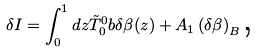Convert formula to latex. <formula><loc_0><loc_0><loc_500><loc_500>\delta I = \int _ { 0 } ^ { 1 } d z \tilde { T } _ { 0 } ^ { 0 } b \delta \beta ( z ) + A _ { 1 } \left ( \delta \beta \right ) _ { B } \text {,}</formula> 